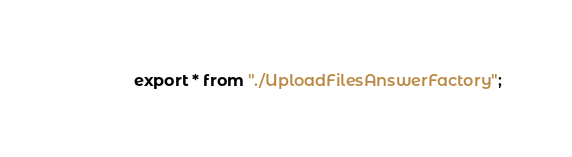<code> <loc_0><loc_0><loc_500><loc_500><_TypeScript_>export * from "./UploadFilesAnswerFactory";
</code> 